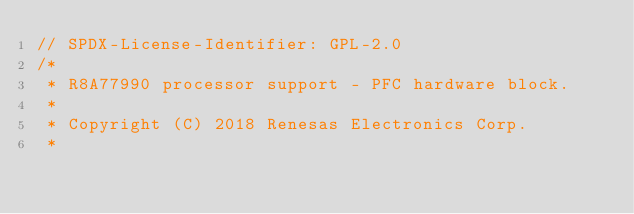<code> <loc_0><loc_0><loc_500><loc_500><_C_>// SPDX-License-Identifier: GPL-2.0
/*
 * R8A77990 processor support - PFC hardware block.
 *
 * Copyright (C) 2018 Renesas Electronics Corp.
 *</code> 